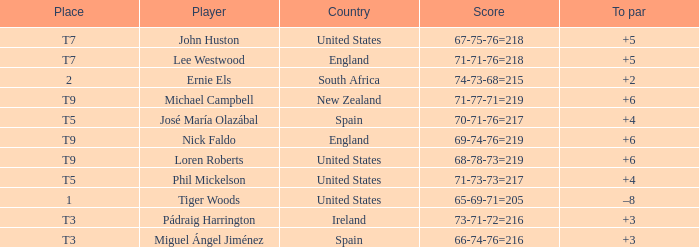What is To Par, when Place is "T5", and when Country is "United States"? 4.0. 